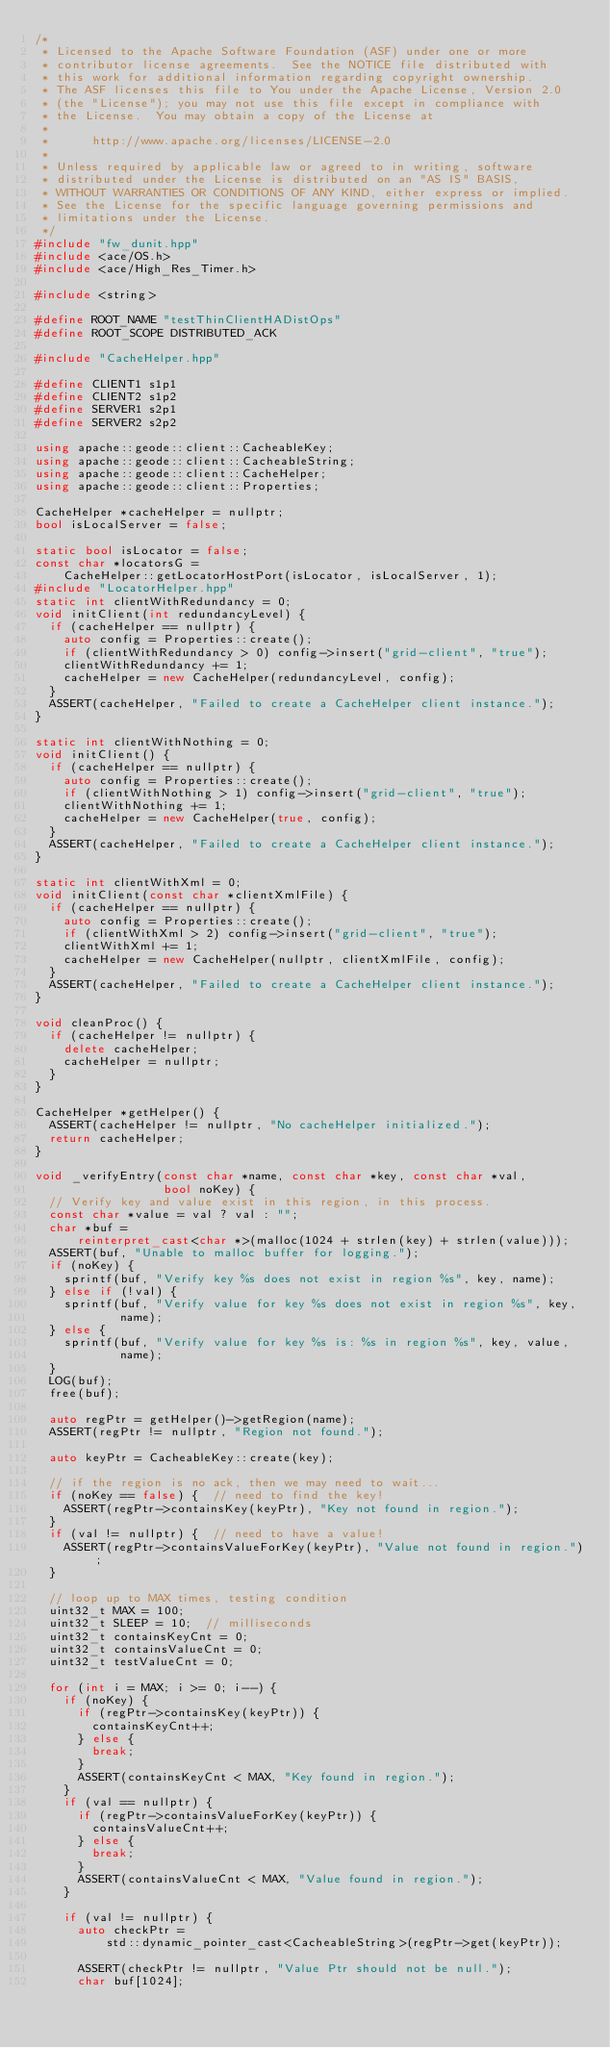<code> <loc_0><loc_0><loc_500><loc_500><_C++_>/*
 * Licensed to the Apache Software Foundation (ASF) under one or more
 * contributor license agreements.  See the NOTICE file distributed with
 * this work for additional information regarding copyright ownership.
 * The ASF licenses this file to You under the Apache License, Version 2.0
 * (the "License"); you may not use this file except in compliance with
 * the License.  You may obtain a copy of the License at
 *
 *      http://www.apache.org/licenses/LICENSE-2.0
 *
 * Unless required by applicable law or agreed to in writing, software
 * distributed under the License is distributed on an "AS IS" BASIS,
 * WITHOUT WARRANTIES OR CONDITIONS OF ANY KIND, either express or implied.
 * See the License for the specific language governing permissions and
 * limitations under the License.
 */
#include "fw_dunit.hpp"
#include <ace/OS.h>
#include <ace/High_Res_Timer.h>

#include <string>

#define ROOT_NAME "testThinClientHADistOps"
#define ROOT_SCOPE DISTRIBUTED_ACK

#include "CacheHelper.hpp"

#define CLIENT1 s1p1
#define CLIENT2 s1p2
#define SERVER1 s2p1
#define SERVER2 s2p2

using apache::geode::client::CacheableKey;
using apache::geode::client::CacheableString;
using apache::geode::client::CacheHelper;
using apache::geode::client::Properties;

CacheHelper *cacheHelper = nullptr;
bool isLocalServer = false;

static bool isLocator = false;
const char *locatorsG =
    CacheHelper::getLocatorHostPort(isLocator, isLocalServer, 1);
#include "LocatorHelper.hpp"
static int clientWithRedundancy = 0;
void initClient(int redundancyLevel) {
  if (cacheHelper == nullptr) {
    auto config = Properties::create();
    if (clientWithRedundancy > 0) config->insert("grid-client", "true");
    clientWithRedundancy += 1;
    cacheHelper = new CacheHelper(redundancyLevel, config);
  }
  ASSERT(cacheHelper, "Failed to create a CacheHelper client instance.");
}

static int clientWithNothing = 0;
void initClient() {
  if (cacheHelper == nullptr) {
    auto config = Properties::create();
    if (clientWithNothing > 1) config->insert("grid-client", "true");
    clientWithNothing += 1;
    cacheHelper = new CacheHelper(true, config);
  }
  ASSERT(cacheHelper, "Failed to create a CacheHelper client instance.");
}

static int clientWithXml = 0;
void initClient(const char *clientXmlFile) {
  if (cacheHelper == nullptr) {
    auto config = Properties::create();
    if (clientWithXml > 2) config->insert("grid-client", "true");
    clientWithXml += 1;
    cacheHelper = new CacheHelper(nullptr, clientXmlFile, config);
  }
  ASSERT(cacheHelper, "Failed to create a CacheHelper client instance.");
}

void cleanProc() {
  if (cacheHelper != nullptr) {
    delete cacheHelper;
    cacheHelper = nullptr;
  }
}

CacheHelper *getHelper() {
  ASSERT(cacheHelper != nullptr, "No cacheHelper initialized.");
  return cacheHelper;
}

void _verifyEntry(const char *name, const char *key, const char *val,
                  bool noKey) {
  // Verify key and value exist in this region, in this process.
  const char *value = val ? val : "";
  char *buf =
      reinterpret_cast<char *>(malloc(1024 + strlen(key) + strlen(value)));
  ASSERT(buf, "Unable to malloc buffer for logging.");
  if (noKey) {
    sprintf(buf, "Verify key %s does not exist in region %s", key, name);
  } else if (!val) {
    sprintf(buf, "Verify value for key %s does not exist in region %s", key,
            name);
  } else {
    sprintf(buf, "Verify value for key %s is: %s in region %s", key, value,
            name);
  }
  LOG(buf);
  free(buf);

  auto regPtr = getHelper()->getRegion(name);
  ASSERT(regPtr != nullptr, "Region not found.");

  auto keyPtr = CacheableKey::create(key);

  // if the region is no ack, then we may need to wait...
  if (noKey == false) {  // need to find the key!
    ASSERT(regPtr->containsKey(keyPtr), "Key not found in region.");
  }
  if (val != nullptr) {  // need to have a value!
    ASSERT(regPtr->containsValueForKey(keyPtr), "Value not found in region.");
  }

  // loop up to MAX times, testing condition
  uint32_t MAX = 100;
  uint32_t SLEEP = 10;  // milliseconds
  uint32_t containsKeyCnt = 0;
  uint32_t containsValueCnt = 0;
  uint32_t testValueCnt = 0;

  for (int i = MAX; i >= 0; i--) {
    if (noKey) {
      if (regPtr->containsKey(keyPtr)) {
        containsKeyCnt++;
      } else {
        break;
      }
      ASSERT(containsKeyCnt < MAX, "Key found in region.");
    }
    if (val == nullptr) {
      if (regPtr->containsValueForKey(keyPtr)) {
        containsValueCnt++;
      } else {
        break;
      }
      ASSERT(containsValueCnt < MAX, "Value found in region.");
    }

    if (val != nullptr) {
      auto checkPtr =
          std::dynamic_pointer_cast<CacheableString>(regPtr->get(keyPtr));

      ASSERT(checkPtr != nullptr, "Value Ptr should not be null.");
      char buf[1024];</code> 